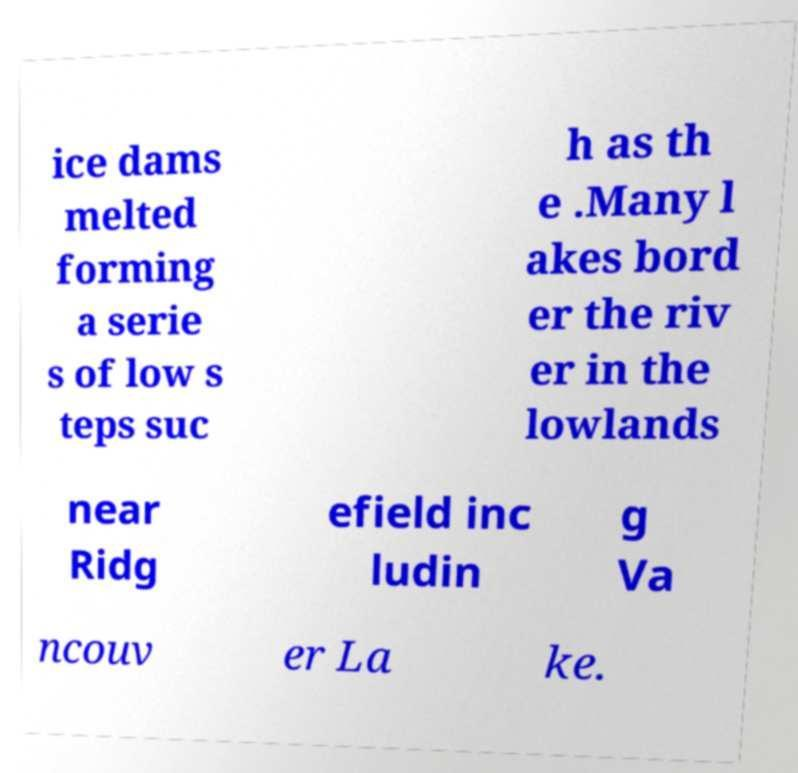Could you extract and type out the text from this image? ice dams melted forming a serie s of low s teps suc h as th e .Many l akes bord er the riv er in the lowlands near Ridg efield inc ludin g Va ncouv er La ke. 